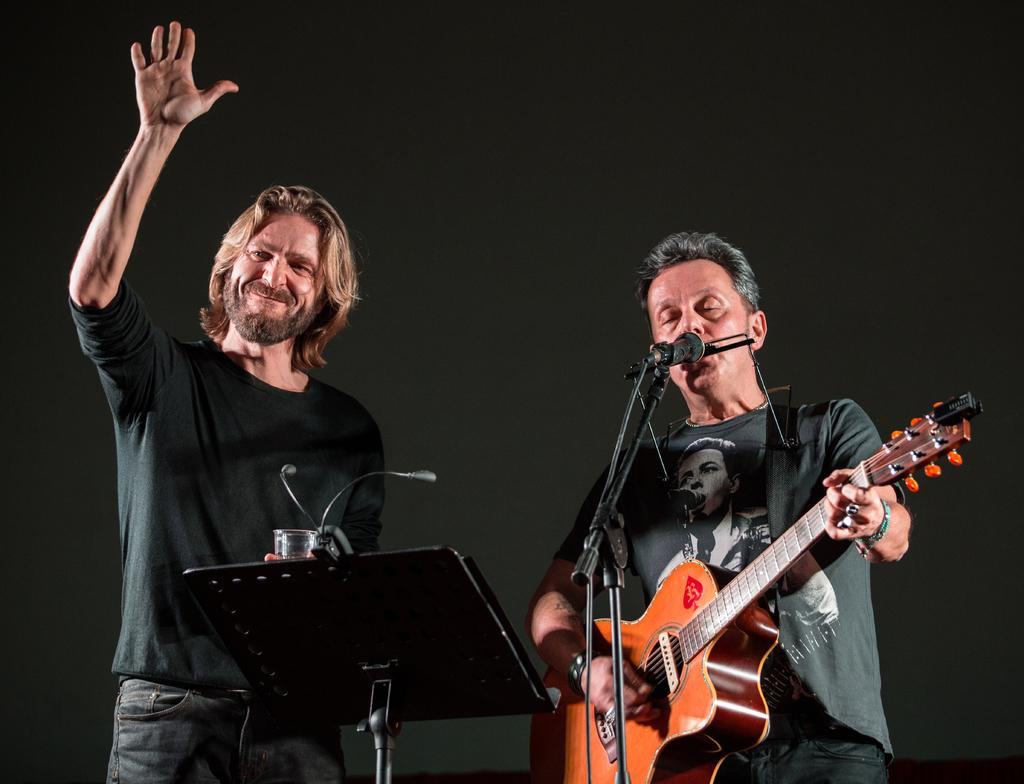What is the man in the black t-shirt doing in the image? The man in the black t-shirt is standing in the image. Can you describe the other man in the image? The second man is wearing a grey shirt and playing a guitar. What is the second man doing in addition to playing the guitar? The second man is also singing in the image. What object is present in the image that is typically used for amplifying sound? There is a microphone in the image. How much dust can be seen on the tooth in the image? There is no tooth present in the image, and therefore no dust can be observed on it. 